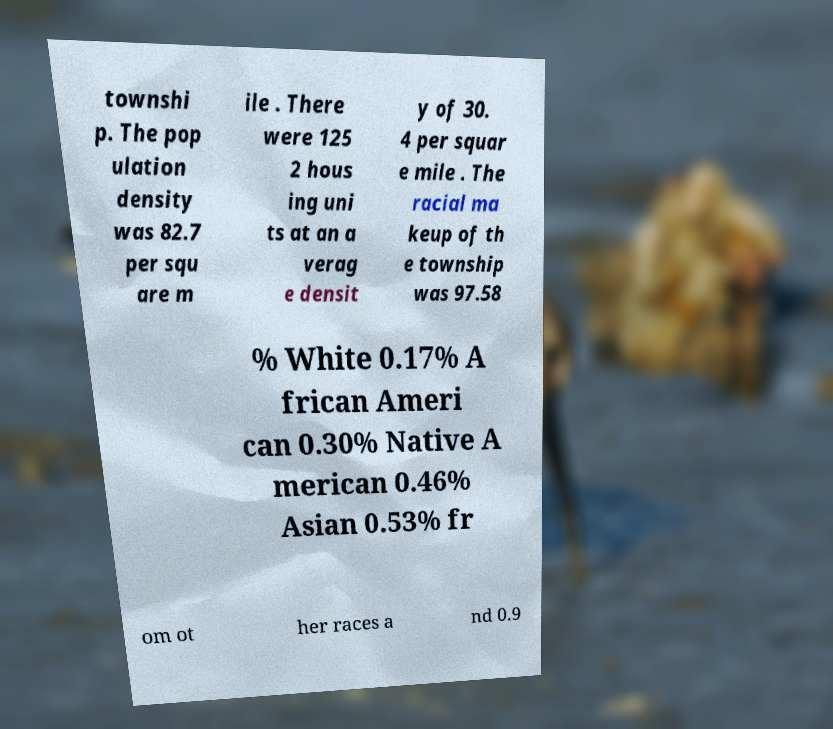What messages or text are displayed in this image? I need them in a readable, typed format. townshi p. The pop ulation density was 82.7 per squ are m ile . There were 125 2 hous ing uni ts at an a verag e densit y of 30. 4 per squar e mile . The racial ma keup of th e township was 97.58 % White 0.17% A frican Ameri can 0.30% Native A merican 0.46% Asian 0.53% fr om ot her races a nd 0.9 